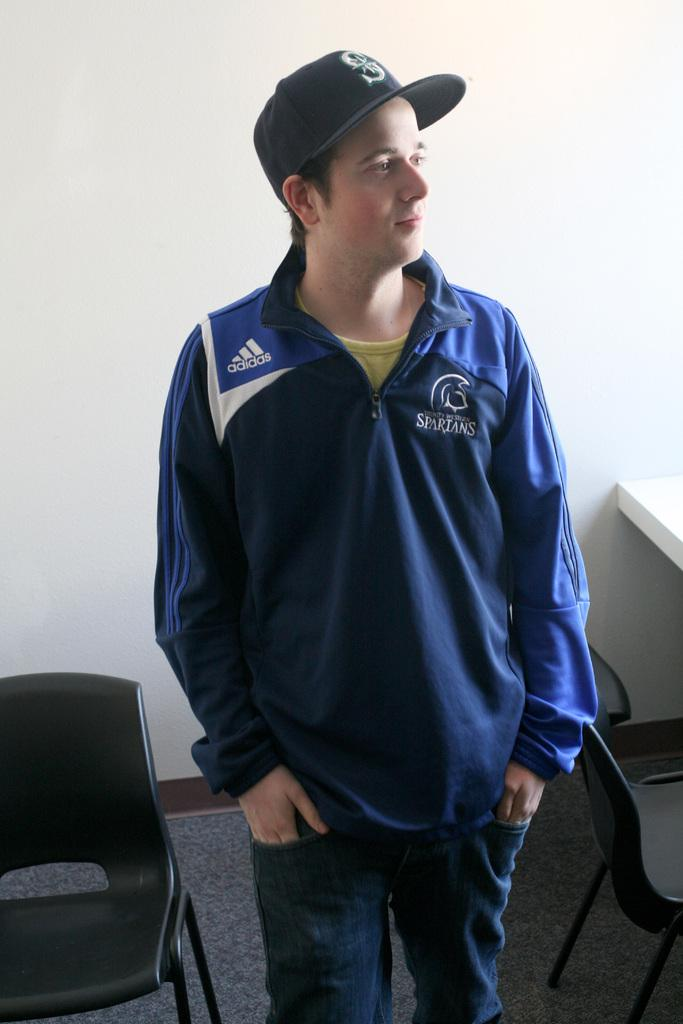<image>
Present a compact description of the photo's key features. a jacket that has the word spartans on it 